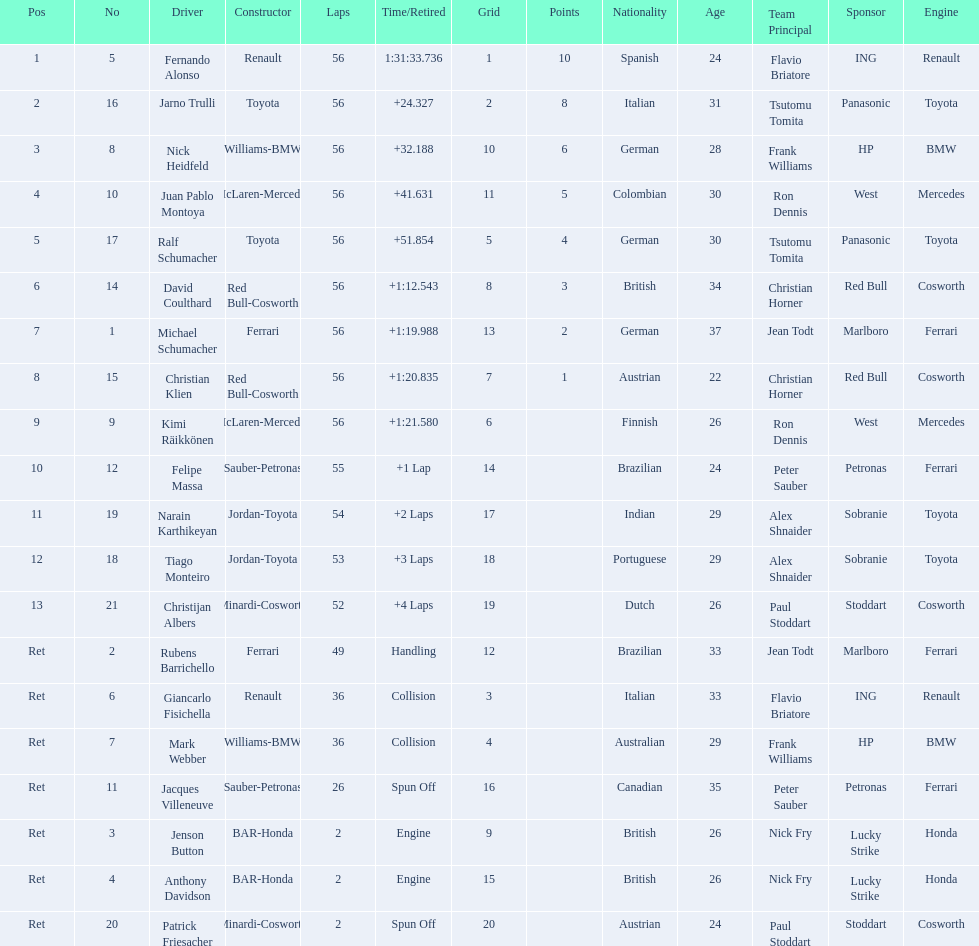How long did it take fernando alonso to finish the race? 1:31:33.736. 